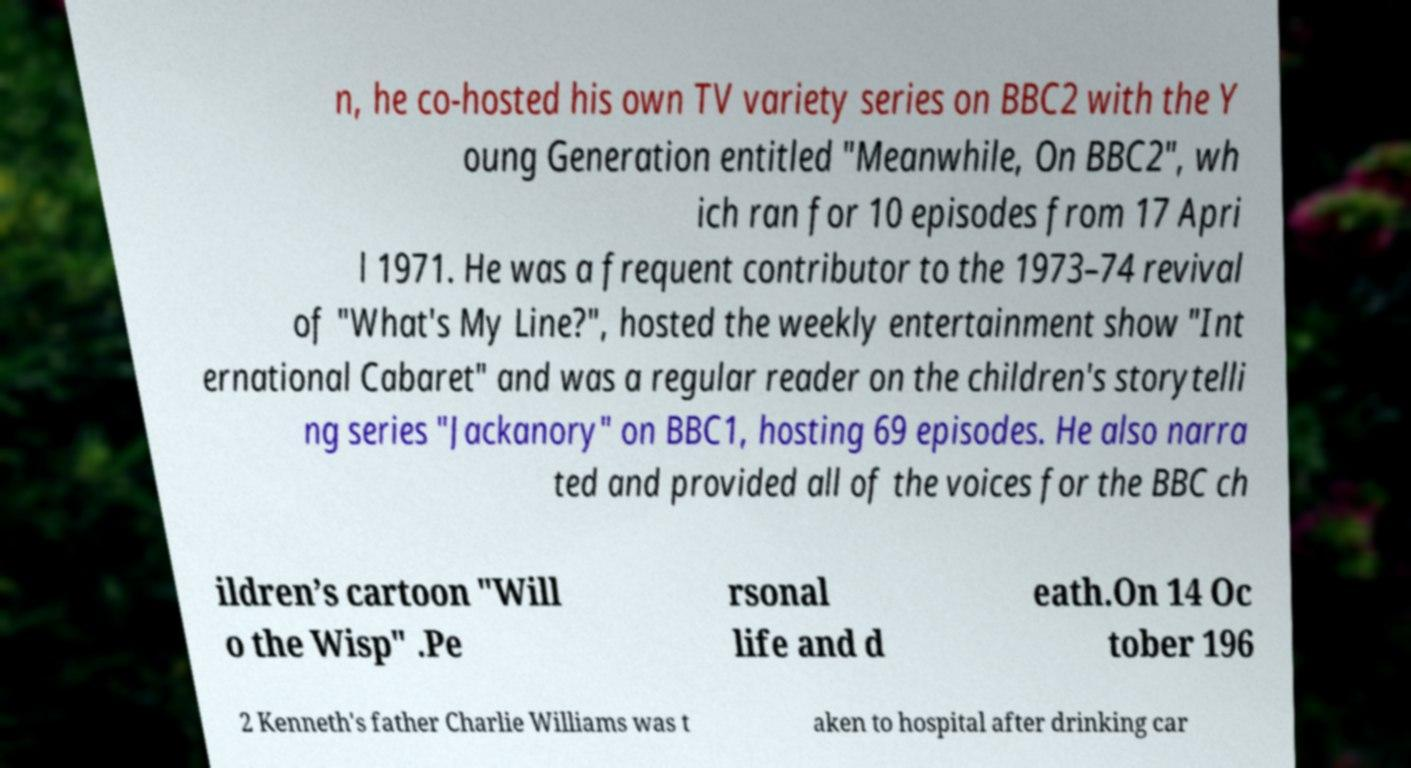There's text embedded in this image that I need extracted. Can you transcribe it verbatim? n, he co-hosted his own TV variety series on BBC2 with the Y oung Generation entitled "Meanwhile, On BBC2", wh ich ran for 10 episodes from 17 Apri l 1971. He was a frequent contributor to the 1973–74 revival of "What's My Line?", hosted the weekly entertainment show "Int ernational Cabaret" and was a regular reader on the children's storytelli ng series "Jackanory" on BBC1, hosting 69 episodes. He also narra ted and provided all of the voices for the BBC ch ildren’s cartoon "Will o the Wisp" .Pe rsonal life and d eath.On 14 Oc tober 196 2 Kenneth's father Charlie Williams was t aken to hospital after drinking car 